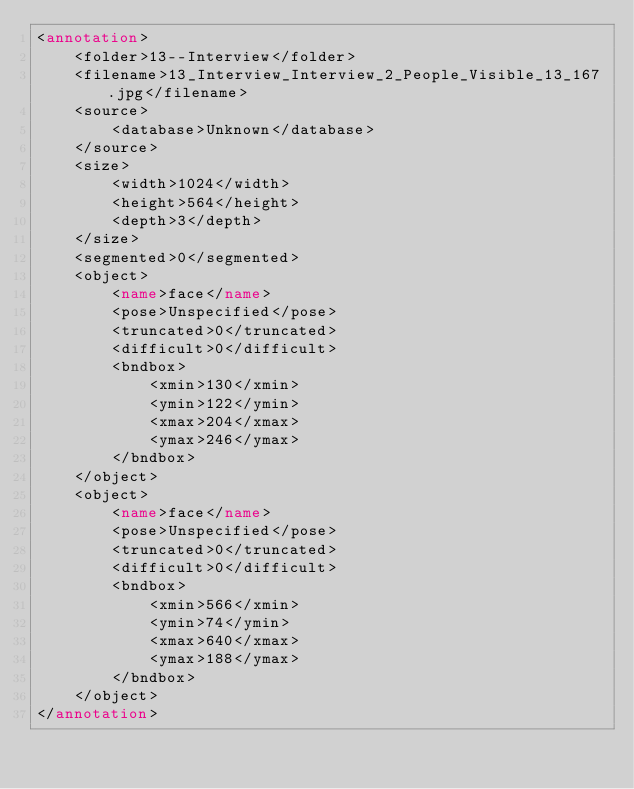<code> <loc_0><loc_0><loc_500><loc_500><_XML_><annotation>
    <folder>13--Interview</folder>
    <filename>13_Interview_Interview_2_People_Visible_13_167.jpg</filename>
    <source>
        <database>Unknown</database>
    </source>
    <size>
        <width>1024</width>
        <height>564</height>
        <depth>3</depth>
    </size>
    <segmented>0</segmented>
    <object>
        <name>face</name>
        <pose>Unspecified</pose>
        <truncated>0</truncated>
        <difficult>0</difficult>
        <bndbox>
            <xmin>130</xmin>
            <ymin>122</ymin>
            <xmax>204</xmax>
            <ymax>246</ymax>
        </bndbox>
    </object>
    <object>
        <name>face</name>
        <pose>Unspecified</pose>
        <truncated>0</truncated>
        <difficult>0</difficult>
        <bndbox>
            <xmin>566</xmin>
            <ymin>74</ymin>
            <xmax>640</xmax>
            <ymax>188</ymax>
        </bndbox>
    </object>
</annotation>
</code> 